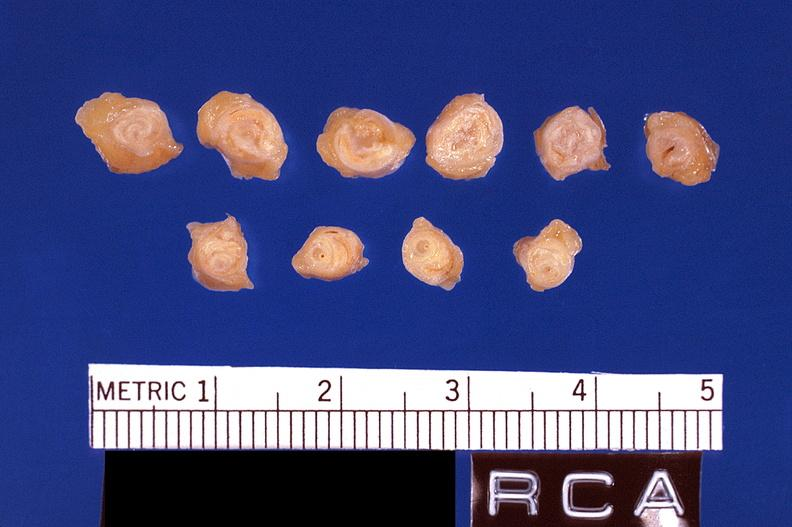where is this?
Answer the question using a single word or phrase. Vasculature 